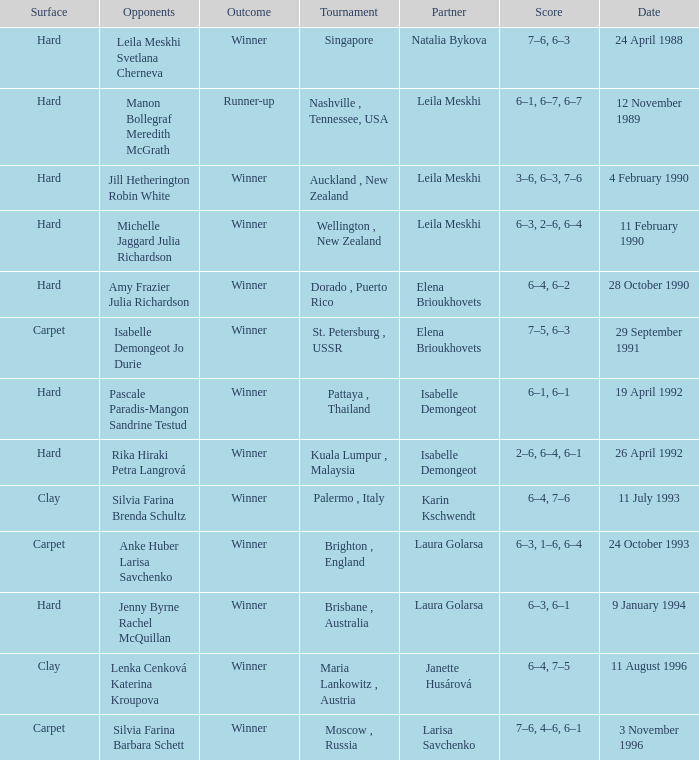When was the score 6-4, 6-2? 28 October 1990. Can you parse all the data within this table? {'header': ['Surface', 'Opponents', 'Outcome', 'Tournament', 'Partner', 'Score', 'Date'], 'rows': [['Hard', 'Leila Meskhi Svetlana Cherneva', 'Winner', 'Singapore', 'Natalia Bykova', '7–6, 6–3', '24 April 1988'], ['Hard', 'Manon Bollegraf Meredith McGrath', 'Runner-up', 'Nashville , Tennessee, USA', 'Leila Meskhi', '6–1, 6–7, 6–7', '12 November 1989'], ['Hard', 'Jill Hetherington Robin White', 'Winner', 'Auckland , New Zealand', 'Leila Meskhi', '3–6, 6–3, 7–6', '4 February 1990'], ['Hard', 'Michelle Jaggard Julia Richardson', 'Winner', 'Wellington , New Zealand', 'Leila Meskhi', '6–3, 2–6, 6–4', '11 February 1990'], ['Hard', 'Amy Frazier Julia Richardson', 'Winner', 'Dorado , Puerto Rico', 'Elena Brioukhovets', '6–4, 6–2', '28 October 1990'], ['Carpet', 'Isabelle Demongeot Jo Durie', 'Winner', 'St. Petersburg , USSR', 'Elena Brioukhovets', '7–5, 6–3', '29 September 1991'], ['Hard', 'Pascale Paradis-Mangon Sandrine Testud', 'Winner', 'Pattaya , Thailand', 'Isabelle Demongeot', '6–1, 6–1', '19 April 1992'], ['Hard', 'Rika Hiraki Petra Langrová', 'Winner', 'Kuala Lumpur , Malaysia', 'Isabelle Demongeot', '2–6, 6–4, 6–1', '26 April 1992'], ['Clay', 'Silvia Farina Brenda Schultz', 'Winner', 'Palermo , Italy', 'Karin Kschwendt', '6–4, 7–6', '11 July 1993'], ['Carpet', 'Anke Huber Larisa Savchenko', 'Winner', 'Brighton , England', 'Laura Golarsa', '6–3, 1–6, 6–4', '24 October 1993'], ['Hard', 'Jenny Byrne Rachel McQuillan', 'Winner', 'Brisbane , Australia', 'Laura Golarsa', '6–3, 6–1', '9 January 1994'], ['Clay', 'Lenka Cenková Katerina Kroupova', 'Winner', 'Maria Lankowitz , Austria', 'Janette Husárová', '6–4, 7–5', '11 August 1996'], ['Carpet', 'Silvia Farina Barbara Schett', 'Winner', 'Moscow , Russia', 'Larisa Savchenko', '7–6, 4–6, 6–1', '3 November 1996']]} 